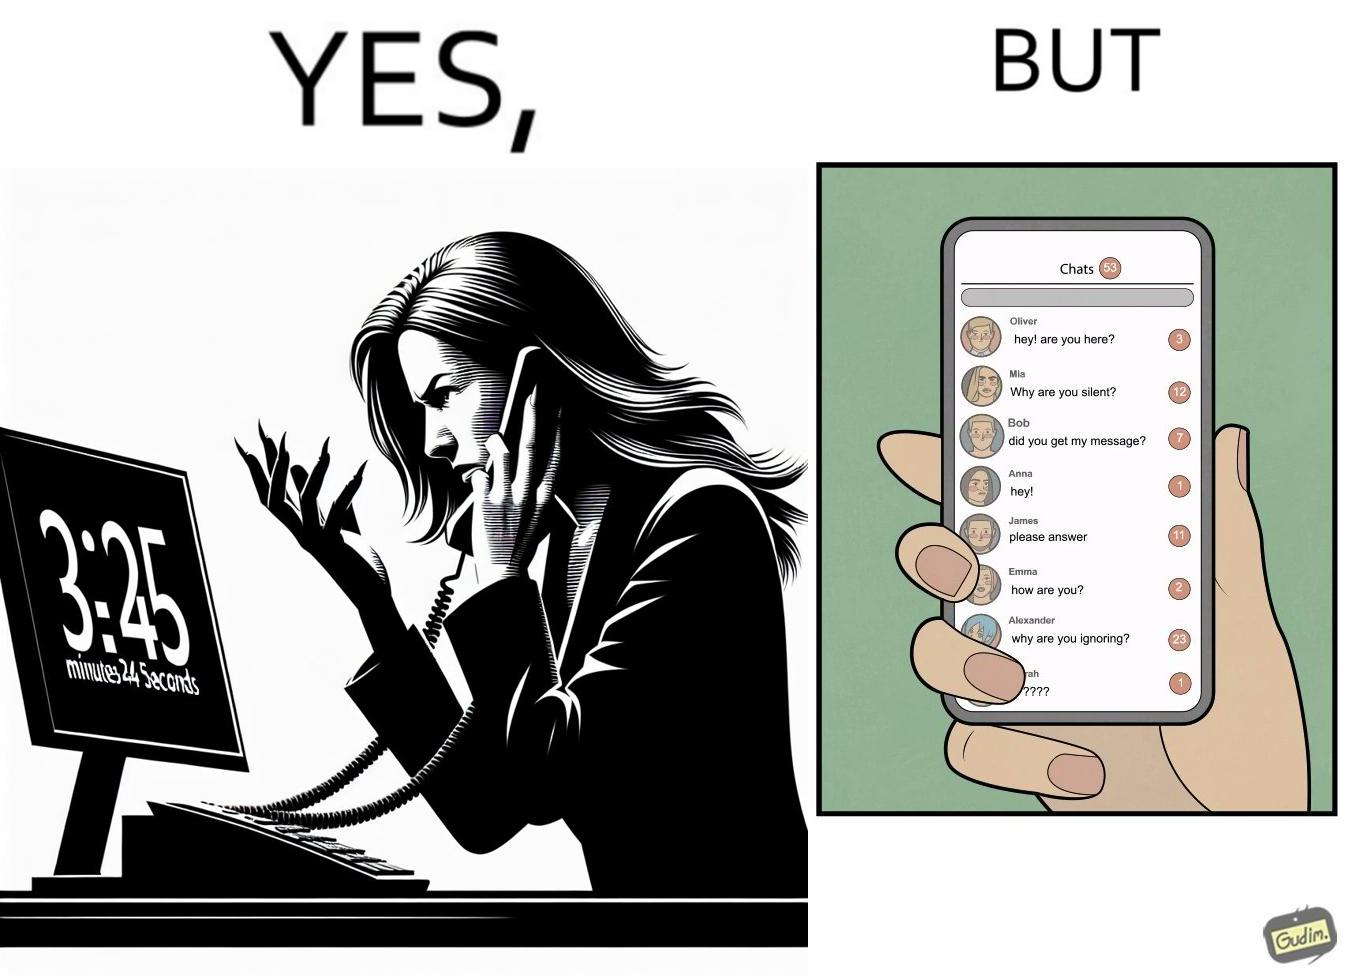Describe the content of this image. The image is ironical because while the woman is annoyed by the unresponsiveness of the call center, she herself is being unresponsive to many people in the chat. 